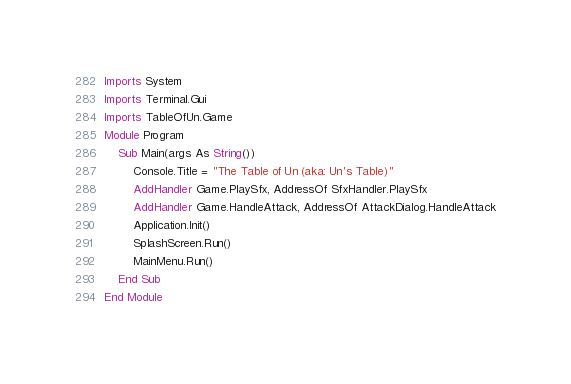Convert code to text. <code><loc_0><loc_0><loc_500><loc_500><_VisualBasic_>Imports System
Imports Terminal.Gui
Imports TableOfUn.Game
Module Program
    Sub Main(args As String())
        Console.Title = "The Table of Un (aka: Un's Table)"
        AddHandler Game.PlaySfx, AddressOf SfxHandler.PlaySfx
        AddHandler Game.HandleAttack, AddressOf AttackDialog.HandleAttack
        Application.Init()
        SplashScreen.Run()
        MainMenu.Run()
    End Sub
End Module
</code> 